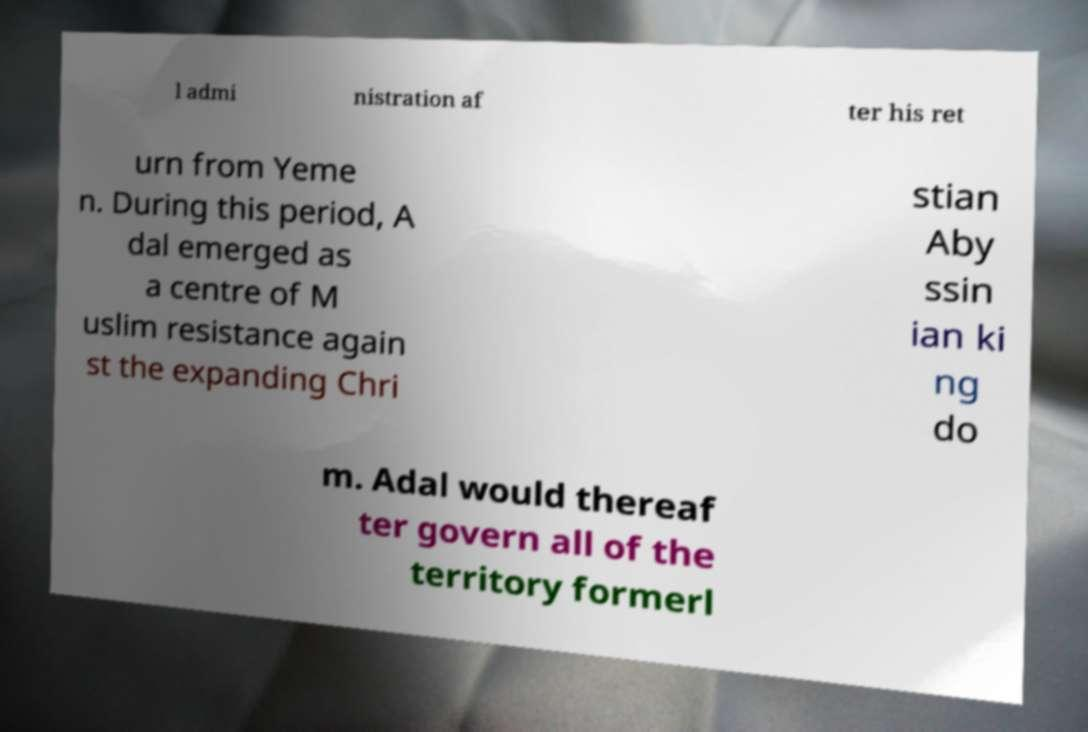For documentation purposes, I need the text within this image transcribed. Could you provide that? l admi nistration af ter his ret urn from Yeme n. During this period, A dal emerged as a centre of M uslim resistance again st the expanding Chri stian Aby ssin ian ki ng do m. Adal would thereaf ter govern all of the territory formerl 